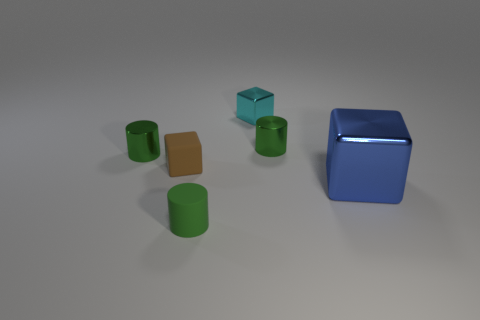How many green cylinders must be subtracted to get 1 green cylinders? 2 Subtract all small shiny cylinders. How many cylinders are left? 1 Add 3 brown matte cubes. How many objects exist? 9 Subtract all brown blocks. How many blocks are left? 2 Subtract 2 blocks. How many blocks are left? 1 Subtract all green blocks. Subtract all green cylinders. How many blocks are left? 3 Subtract all yellow cylinders. Subtract all brown things. How many objects are left? 5 Add 3 large blue things. How many large blue things are left? 4 Add 5 green things. How many green things exist? 8 Subtract 0 cyan cylinders. How many objects are left? 6 